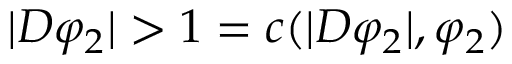<formula> <loc_0><loc_0><loc_500><loc_500>| D \varphi _ { 2 } | > 1 = c ( | D \varphi _ { 2 } | , \varphi _ { 2 } )</formula> 